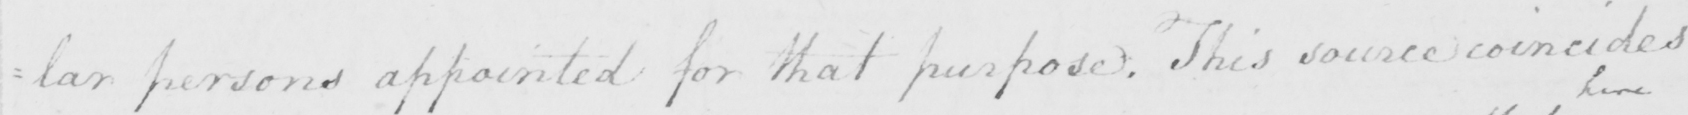What does this handwritten line say? : lar persons appointed for that purpose . This source coincides 